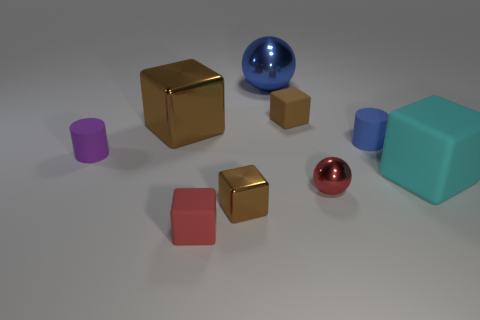There is a small thing that is the same color as the tiny metal ball; what material is it?
Offer a very short reply. Rubber. There is a shiny ball that is on the right side of the blue shiny object; is it the same size as the big ball?
Keep it short and to the point. No. How many rubber things are on the right side of the small shiny sphere and in front of the purple rubber cylinder?
Your answer should be very brief. 1. There is a brown metal cube that is behind the rubber cylinder left of the blue rubber cylinder; what is its size?
Offer a very short reply. Large. Is the number of blue spheres that are in front of the big cyan block less than the number of large blue things to the right of the tiny sphere?
Your answer should be compact. No. There is a small rubber cube that is behind the small blue matte cylinder; is its color the same as the shiny object that is in front of the small red sphere?
Give a very brief answer. Yes. The big object that is in front of the big blue thing and behind the big matte thing is made of what material?
Your response must be concise. Metal. Are there any small blue matte cubes?
Your answer should be very brief. No. There is a brown thing that is made of the same material as the purple thing; what shape is it?
Your answer should be very brief. Cube. Do the small brown shiny thing and the big thing to the left of the tiny red cube have the same shape?
Your answer should be very brief. Yes. 